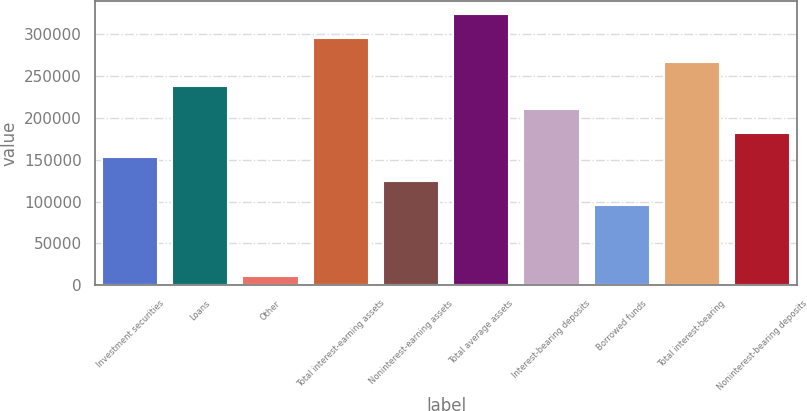Convert chart to OTSL. <chart><loc_0><loc_0><loc_500><loc_500><bar_chart><fcel>Investment securities<fcel>Loans<fcel>Other<fcel>Total interest-earning assets<fcel>Noninterest-earning assets<fcel>Total average assets<fcel>Interest-bearing deposits<fcel>Borrowed funds<fcel>Total interest-bearing<fcel>Noninterest-bearing deposits<nl><fcel>153072<fcel>238244<fcel>11120<fcel>295025<fcel>124682<fcel>323416<fcel>209854<fcel>96291.5<fcel>266634<fcel>181463<nl></chart> 